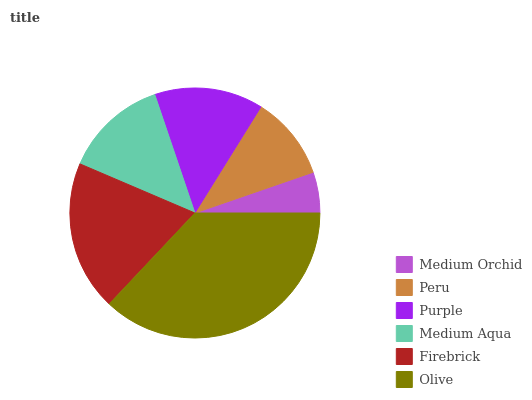Is Medium Orchid the minimum?
Answer yes or no. Yes. Is Olive the maximum?
Answer yes or no. Yes. Is Peru the minimum?
Answer yes or no. No. Is Peru the maximum?
Answer yes or no. No. Is Peru greater than Medium Orchid?
Answer yes or no. Yes. Is Medium Orchid less than Peru?
Answer yes or no. Yes. Is Medium Orchid greater than Peru?
Answer yes or no. No. Is Peru less than Medium Orchid?
Answer yes or no. No. Is Purple the high median?
Answer yes or no. Yes. Is Medium Aqua the low median?
Answer yes or no. Yes. Is Medium Aqua the high median?
Answer yes or no. No. Is Firebrick the low median?
Answer yes or no. No. 